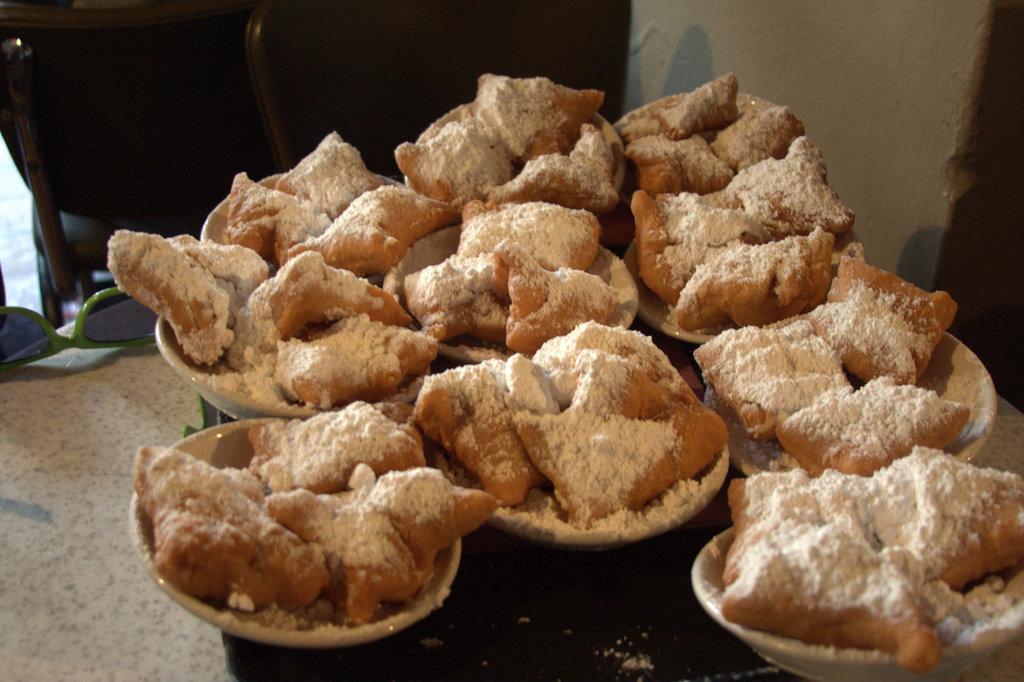How would you summarize this image in a sentence or two? In this image I can see few food items in the bowels and the food items are in brown and white color and the background is in white and black color. 